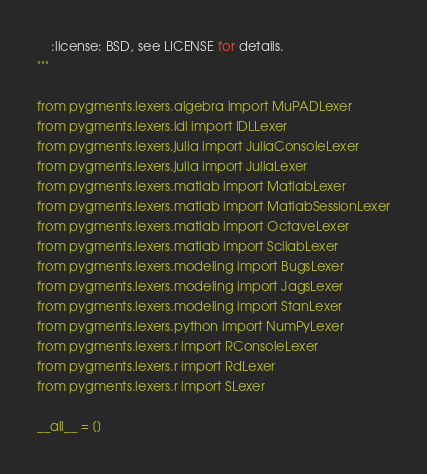Convert code to text. <code><loc_0><loc_0><loc_500><loc_500><_Python_>    :license: BSD, see LICENSE for details.
"""

from pygments.lexers.algebra import MuPADLexer
from pygments.lexers.idl import IDLLexer
from pygments.lexers.julia import JuliaConsoleLexer
from pygments.lexers.julia import JuliaLexer
from pygments.lexers.matlab import MatlabLexer
from pygments.lexers.matlab import MatlabSessionLexer
from pygments.lexers.matlab import OctaveLexer
from pygments.lexers.matlab import ScilabLexer
from pygments.lexers.modeling import BugsLexer
from pygments.lexers.modeling import JagsLexer
from pygments.lexers.modeling import StanLexer
from pygments.lexers.python import NumPyLexer
from pygments.lexers.r import RConsoleLexer
from pygments.lexers.r import RdLexer
from pygments.lexers.r import SLexer

__all__ = []
</code> 